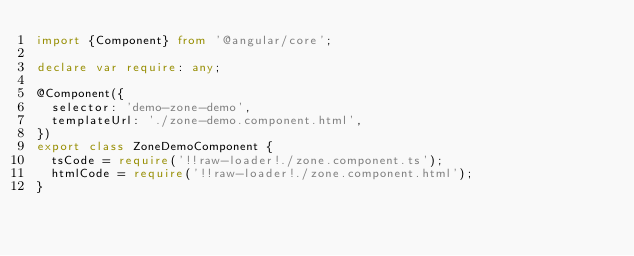<code> <loc_0><loc_0><loc_500><loc_500><_TypeScript_>import {Component} from '@angular/core';

declare var require: any;

@Component({
  selector: 'demo-zone-demo',
  templateUrl: './zone-demo.component.html',
})
export class ZoneDemoComponent {
  tsCode = require('!!raw-loader!./zone.component.ts');
  htmlCode = require('!!raw-loader!./zone.component.html');
}
</code> 